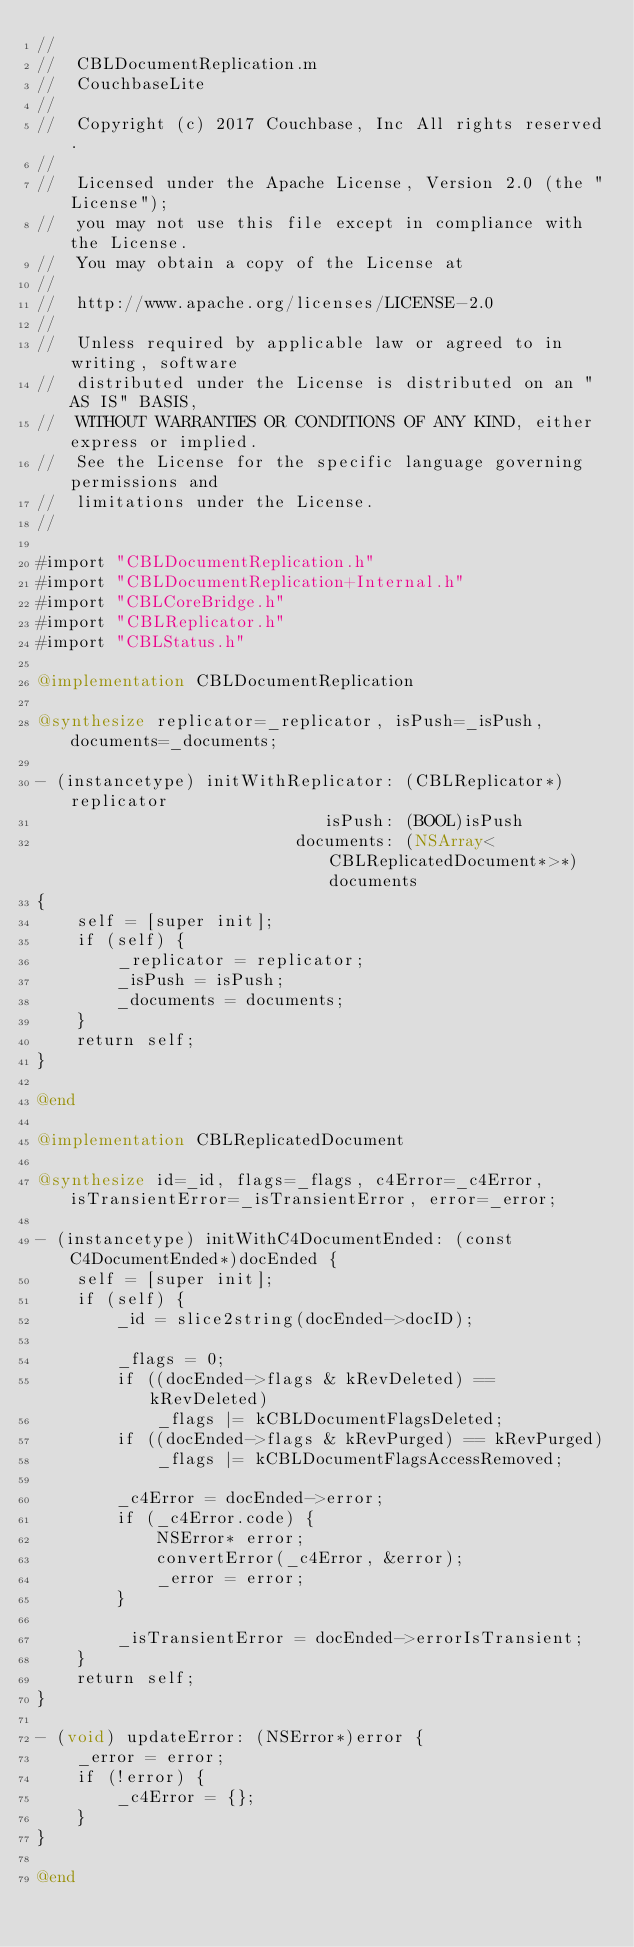Convert code to text. <code><loc_0><loc_0><loc_500><loc_500><_ObjectiveC_>//
//  CBLDocumentReplication.m
//  CouchbaseLite
//
//  Copyright (c) 2017 Couchbase, Inc All rights reserved.
//
//  Licensed under the Apache License, Version 2.0 (the "License");
//  you may not use this file except in compliance with the License.
//  You may obtain a copy of the License at
//
//  http://www.apache.org/licenses/LICENSE-2.0
//
//  Unless required by applicable law or agreed to in writing, software
//  distributed under the License is distributed on an "AS IS" BASIS,
//  WITHOUT WARRANTIES OR CONDITIONS OF ANY KIND, either express or implied.
//  See the License for the specific language governing permissions and
//  limitations under the License.
//

#import "CBLDocumentReplication.h"
#import "CBLDocumentReplication+Internal.h"
#import "CBLCoreBridge.h"
#import "CBLReplicator.h"
#import "CBLStatus.h"

@implementation CBLDocumentReplication

@synthesize replicator=_replicator, isPush=_isPush, documents=_documents;

- (instancetype) initWithReplicator: (CBLReplicator*)replicator
                             isPush: (BOOL)isPush
                          documents: (NSArray<CBLReplicatedDocument*>*)documents
{
    self = [super init];
    if (self) {
        _replicator = replicator;
        _isPush = isPush;
        _documents = documents;
    }
    return self;
}

@end

@implementation CBLReplicatedDocument

@synthesize id=_id, flags=_flags, c4Error=_c4Error, isTransientError=_isTransientError, error=_error;

- (instancetype) initWithC4DocumentEnded: (const C4DocumentEnded*)docEnded {
    self = [super init];
    if (self) {
        _id = slice2string(docEnded->docID);
        
        _flags = 0;
        if ((docEnded->flags & kRevDeleted) == kRevDeleted)
            _flags |= kCBLDocumentFlagsDeleted;
        if ((docEnded->flags & kRevPurged) == kRevPurged)
            _flags |= kCBLDocumentFlagsAccessRemoved;
        
        _c4Error = docEnded->error;
        if (_c4Error.code) {
            NSError* error;
            convertError(_c4Error, &error);
            _error = error;
        }
        
        _isTransientError = docEnded->errorIsTransient;
    }
    return self;
}

- (void) updateError: (NSError*)error {
    _error = error;
    if (!error) {
        _c4Error = {};
    }
}

@end
</code> 